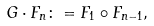<formula> <loc_0><loc_0><loc_500><loc_500>G \cdot F _ { n } \colon = F _ { 1 } \circ F _ { n - 1 } ,</formula> 